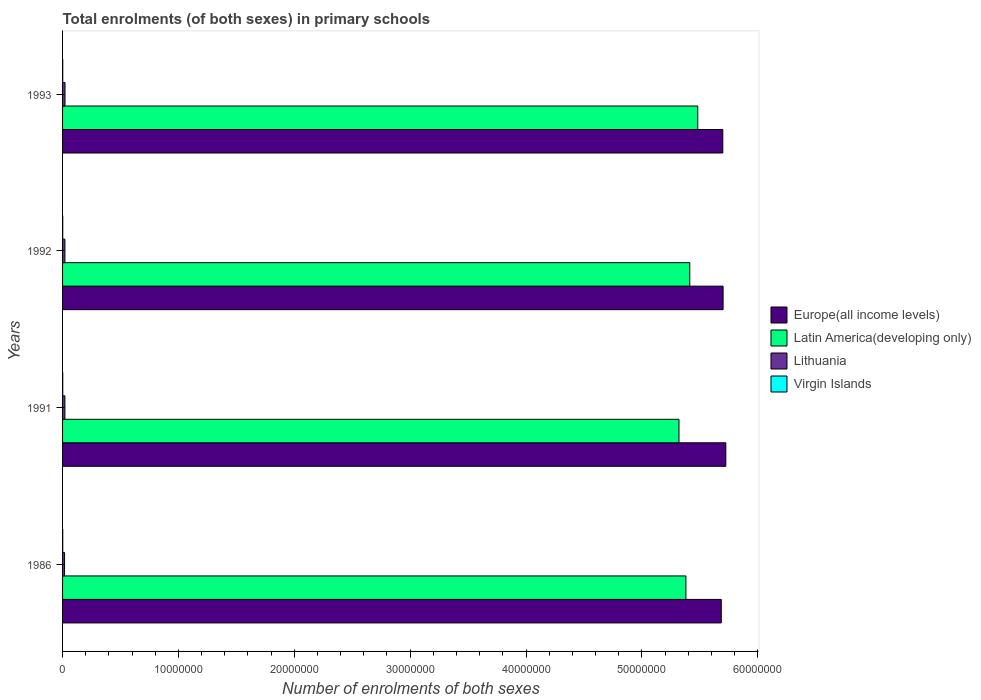Are the number of bars on each tick of the Y-axis equal?
Make the answer very short. Yes. How many bars are there on the 1st tick from the bottom?
Make the answer very short. 4. What is the number of enrolments in primary schools in Latin America(developing only) in 1993?
Your response must be concise. 5.48e+07. Across all years, what is the maximum number of enrolments in primary schools in Europe(all income levels)?
Keep it short and to the point. 5.72e+07. Across all years, what is the minimum number of enrolments in primary schools in Europe(all income levels)?
Ensure brevity in your answer.  5.69e+07. In which year was the number of enrolments in primary schools in Virgin Islands maximum?
Offer a terse response. 1986. What is the total number of enrolments in primary schools in Virgin Islands in the graph?
Your answer should be very brief. 5.82e+04. What is the difference between the number of enrolments in primary schools in Virgin Islands in 1992 and that in 1993?
Keep it short and to the point. -144. What is the difference between the number of enrolments in primary schools in Europe(all income levels) in 1992 and the number of enrolments in primary schools in Latin America(developing only) in 1986?
Offer a terse response. 3.21e+06. What is the average number of enrolments in primary schools in Lithuania per year?
Offer a very short reply. 1.97e+05. In the year 1991, what is the difference between the number of enrolments in primary schools in Virgin Islands and number of enrolments in primary schools in Europe(all income levels)?
Offer a terse response. -5.72e+07. In how many years, is the number of enrolments in primary schools in Virgin Islands greater than 4000000 ?
Offer a terse response. 0. What is the ratio of the number of enrolments in primary schools in Latin America(developing only) in 1986 to that in 1993?
Ensure brevity in your answer.  0.98. What is the difference between the highest and the second highest number of enrolments in primary schools in Europe(all income levels)?
Your answer should be very brief. 2.35e+05. What is the difference between the highest and the lowest number of enrolments in primary schools in Europe(all income levels)?
Keep it short and to the point. 3.91e+05. Is it the case that in every year, the sum of the number of enrolments in primary schools in Virgin Islands and number of enrolments in primary schools in Europe(all income levels) is greater than the sum of number of enrolments in primary schools in Lithuania and number of enrolments in primary schools in Latin America(developing only)?
Make the answer very short. No. What does the 2nd bar from the top in 1986 represents?
Provide a short and direct response. Lithuania. What does the 4th bar from the bottom in 1992 represents?
Provide a succinct answer. Virgin Islands. Are all the bars in the graph horizontal?
Ensure brevity in your answer.  Yes. How many years are there in the graph?
Give a very brief answer. 4. What is the difference between two consecutive major ticks on the X-axis?
Your response must be concise. 1.00e+07. Does the graph contain any zero values?
Offer a terse response. No. Does the graph contain grids?
Ensure brevity in your answer.  No. What is the title of the graph?
Give a very brief answer. Total enrolments (of both sexes) in primary schools. What is the label or title of the X-axis?
Your answer should be very brief. Number of enrolments of both sexes. What is the label or title of the Y-axis?
Provide a short and direct response. Years. What is the Number of enrolments of both sexes in Europe(all income levels) in 1986?
Your answer should be very brief. 5.69e+07. What is the Number of enrolments of both sexes of Latin America(developing only) in 1986?
Provide a succinct answer. 5.38e+07. What is the Number of enrolments of both sexes in Lithuania in 1986?
Your answer should be very brief. 1.72e+05. What is the Number of enrolments of both sexes of Virgin Islands in 1986?
Offer a very short reply. 1.49e+04. What is the Number of enrolments of both sexes in Europe(all income levels) in 1991?
Offer a very short reply. 5.72e+07. What is the Number of enrolments of both sexes in Latin America(developing only) in 1991?
Keep it short and to the point. 5.32e+07. What is the Number of enrolments of both sexes of Lithuania in 1991?
Provide a short and direct response. 2.02e+05. What is the Number of enrolments of both sexes in Virgin Islands in 1991?
Keep it short and to the point. 1.43e+04. What is the Number of enrolments of both sexes of Europe(all income levels) in 1992?
Offer a very short reply. 5.70e+07. What is the Number of enrolments of both sexes of Latin America(developing only) in 1992?
Your answer should be compact. 5.41e+07. What is the Number of enrolments of both sexes of Lithuania in 1992?
Your answer should be compact. 2.03e+05. What is the Number of enrolments of both sexes of Virgin Islands in 1992?
Make the answer very short. 1.44e+04. What is the Number of enrolments of both sexes in Europe(all income levels) in 1993?
Ensure brevity in your answer.  5.70e+07. What is the Number of enrolments of both sexes of Latin America(developing only) in 1993?
Offer a terse response. 5.48e+07. What is the Number of enrolments of both sexes in Lithuania in 1993?
Provide a succinct answer. 2.11e+05. What is the Number of enrolments of both sexes of Virgin Islands in 1993?
Ensure brevity in your answer.  1.45e+04. Across all years, what is the maximum Number of enrolments of both sexes of Europe(all income levels)?
Keep it short and to the point. 5.72e+07. Across all years, what is the maximum Number of enrolments of both sexes in Latin America(developing only)?
Give a very brief answer. 5.48e+07. Across all years, what is the maximum Number of enrolments of both sexes in Lithuania?
Your response must be concise. 2.11e+05. Across all years, what is the maximum Number of enrolments of both sexes in Virgin Islands?
Offer a very short reply. 1.49e+04. Across all years, what is the minimum Number of enrolments of both sexes in Europe(all income levels)?
Give a very brief answer. 5.69e+07. Across all years, what is the minimum Number of enrolments of both sexes of Latin America(developing only)?
Provide a short and direct response. 5.32e+07. Across all years, what is the minimum Number of enrolments of both sexes of Lithuania?
Provide a succinct answer. 1.72e+05. Across all years, what is the minimum Number of enrolments of both sexes of Virgin Islands?
Your answer should be compact. 1.43e+04. What is the total Number of enrolments of both sexes of Europe(all income levels) in the graph?
Keep it short and to the point. 2.28e+08. What is the total Number of enrolments of both sexes of Latin America(developing only) in the graph?
Make the answer very short. 2.16e+08. What is the total Number of enrolments of both sexes in Lithuania in the graph?
Your answer should be very brief. 7.88e+05. What is the total Number of enrolments of both sexes in Virgin Islands in the graph?
Provide a short and direct response. 5.82e+04. What is the difference between the Number of enrolments of both sexes of Europe(all income levels) in 1986 and that in 1991?
Keep it short and to the point. -3.91e+05. What is the difference between the Number of enrolments of both sexes in Latin America(developing only) in 1986 and that in 1991?
Make the answer very short. 5.98e+05. What is the difference between the Number of enrolments of both sexes of Lithuania in 1986 and that in 1991?
Ensure brevity in your answer.  -2.99e+04. What is the difference between the Number of enrolments of both sexes of Virgin Islands in 1986 and that in 1991?
Offer a terse response. 629. What is the difference between the Number of enrolments of both sexes in Europe(all income levels) in 1986 and that in 1992?
Your response must be concise. -1.56e+05. What is the difference between the Number of enrolments of both sexes in Latin America(developing only) in 1986 and that in 1992?
Ensure brevity in your answer.  -3.33e+05. What is the difference between the Number of enrolments of both sexes in Lithuania in 1986 and that in 1992?
Your response must be concise. -3.06e+04. What is the difference between the Number of enrolments of both sexes in Virgin Islands in 1986 and that in 1992?
Provide a succinct answer. 548. What is the difference between the Number of enrolments of both sexes in Europe(all income levels) in 1986 and that in 1993?
Offer a very short reply. -1.30e+05. What is the difference between the Number of enrolments of both sexes in Latin America(developing only) in 1986 and that in 1993?
Make the answer very short. -1.02e+06. What is the difference between the Number of enrolments of both sexes in Lithuania in 1986 and that in 1993?
Your answer should be very brief. -3.85e+04. What is the difference between the Number of enrolments of both sexes in Virgin Islands in 1986 and that in 1993?
Keep it short and to the point. 404. What is the difference between the Number of enrolments of both sexes in Europe(all income levels) in 1991 and that in 1992?
Provide a succinct answer. 2.35e+05. What is the difference between the Number of enrolments of both sexes of Latin America(developing only) in 1991 and that in 1992?
Make the answer very short. -9.30e+05. What is the difference between the Number of enrolments of both sexes of Lithuania in 1991 and that in 1992?
Ensure brevity in your answer.  -748. What is the difference between the Number of enrolments of both sexes of Virgin Islands in 1991 and that in 1992?
Ensure brevity in your answer.  -81. What is the difference between the Number of enrolments of both sexes in Europe(all income levels) in 1991 and that in 1993?
Keep it short and to the point. 2.60e+05. What is the difference between the Number of enrolments of both sexes in Latin America(developing only) in 1991 and that in 1993?
Provide a short and direct response. -1.62e+06. What is the difference between the Number of enrolments of both sexes in Lithuania in 1991 and that in 1993?
Your answer should be compact. -8612. What is the difference between the Number of enrolments of both sexes of Virgin Islands in 1991 and that in 1993?
Ensure brevity in your answer.  -225. What is the difference between the Number of enrolments of both sexes of Europe(all income levels) in 1992 and that in 1993?
Provide a succinct answer. 2.56e+04. What is the difference between the Number of enrolments of both sexes of Latin America(developing only) in 1992 and that in 1993?
Your response must be concise. -6.89e+05. What is the difference between the Number of enrolments of both sexes of Lithuania in 1992 and that in 1993?
Make the answer very short. -7864. What is the difference between the Number of enrolments of both sexes in Virgin Islands in 1992 and that in 1993?
Your answer should be very brief. -144. What is the difference between the Number of enrolments of both sexes of Europe(all income levels) in 1986 and the Number of enrolments of both sexes of Latin America(developing only) in 1991?
Give a very brief answer. 3.65e+06. What is the difference between the Number of enrolments of both sexes of Europe(all income levels) in 1986 and the Number of enrolments of both sexes of Lithuania in 1991?
Offer a very short reply. 5.67e+07. What is the difference between the Number of enrolments of both sexes in Europe(all income levels) in 1986 and the Number of enrolments of both sexes in Virgin Islands in 1991?
Your response must be concise. 5.68e+07. What is the difference between the Number of enrolments of both sexes in Latin America(developing only) in 1986 and the Number of enrolments of both sexes in Lithuania in 1991?
Make the answer very short. 5.36e+07. What is the difference between the Number of enrolments of both sexes in Latin America(developing only) in 1986 and the Number of enrolments of both sexes in Virgin Islands in 1991?
Make the answer very short. 5.38e+07. What is the difference between the Number of enrolments of both sexes of Lithuania in 1986 and the Number of enrolments of both sexes of Virgin Islands in 1991?
Offer a terse response. 1.58e+05. What is the difference between the Number of enrolments of both sexes of Europe(all income levels) in 1986 and the Number of enrolments of both sexes of Latin America(developing only) in 1992?
Offer a very short reply. 2.72e+06. What is the difference between the Number of enrolments of both sexes of Europe(all income levels) in 1986 and the Number of enrolments of both sexes of Lithuania in 1992?
Ensure brevity in your answer.  5.67e+07. What is the difference between the Number of enrolments of both sexes of Europe(all income levels) in 1986 and the Number of enrolments of both sexes of Virgin Islands in 1992?
Your answer should be very brief. 5.68e+07. What is the difference between the Number of enrolments of both sexes of Latin America(developing only) in 1986 and the Number of enrolments of both sexes of Lithuania in 1992?
Your answer should be very brief. 5.36e+07. What is the difference between the Number of enrolments of both sexes in Latin America(developing only) in 1986 and the Number of enrolments of both sexes in Virgin Islands in 1992?
Make the answer very short. 5.38e+07. What is the difference between the Number of enrolments of both sexes in Lithuania in 1986 and the Number of enrolments of both sexes in Virgin Islands in 1992?
Give a very brief answer. 1.58e+05. What is the difference between the Number of enrolments of both sexes in Europe(all income levels) in 1986 and the Number of enrolments of both sexes in Latin America(developing only) in 1993?
Your answer should be compact. 2.03e+06. What is the difference between the Number of enrolments of both sexes of Europe(all income levels) in 1986 and the Number of enrolments of both sexes of Lithuania in 1993?
Your answer should be compact. 5.66e+07. What is the difference between the Number of enrolments of both sexes of Europe(all income levels) in 1986 and the Number of enrolments of both sexes of Virgin Islands in 1993?
Offer a very short reply. 5.68e+07. What is the difference between the Number of enrolments of both sexes in Latin America(developing only) in 1986 and the Number of enrolments of both sexes in Lithuania in 1993?
Your response must be concise. 5.36e+07. What is the difference between the Number of enrolments of both sexes in Latin America(developing only) in 1986 and the Number of enrolments of both sexes in Virgin Islands in 1993?
Your answer should be compact. 5.38e+07. What is the difference between the Number of enrolments of both sexes of Lithuania in 1986 and the Number of enrolments of both sexes of Virgin Islands in 1993?
Offer a terse response. 1.58e+05. What is the difference between the Number of enrolments of both sexes in Europe(all income levels) in 1991 and the Number of enrolments of both sexes in Latin America(developing only) in 1992?
Provide a short and direct response. 3.11e+06. What is the difference between the Number of enrolments of both sexes of Europe(all income levels) in 1991 and the Number of enrolments of both sexes of Lithuania in 1992?
Keep it short and to the point. 5.70e+07. What is the difference between the Number of enrolments of both sexes of Europe(all income levels) in 1991 and the Number of enrolments of both sexes of Virgin Islands in 1992?
Offer a terse response. 5.72e+07. What is the difference between the Number of enrolments of both sexes of Latin America(developing only) in 1991 and the Number of enrolments of both sexes of Lithuania in 1992?
Your response must be concise. 5.30e+07. What is the difference between the Number of enrolments of both sexes of Latin America(developing only) in 1991 and the Number of enrolments of both sexes of Virgin Islands in 1992?
Ensure brevity in your answer.  5.32e+07. What is the difference between the Number of enrolments of both sexes in Lithuania in 1991 and the Number of enrolments of both sexes in Virgin Islands in 1992?
Keep it short and to the point. 1.88e+05. What is the difference between the Number of enrolments of both sexes of Europe(all income levels) in 1991 and the Number of enrolments of both sexes of Latin America(developing only) in 1993?
Your answer should be compact. 2.42e+06. What is the difference between the Number of enrolments of both sexes of Europe(all income levels) in 1991 and the Number of enrolments of both sexes of Lithuania in 1993?
Your answer should be very brief. 5.70e+07. What is the difference between the Number of enrolments of both sexes of Europe(all income levels) in 1991 and the Number of enrolments of both sexes of Virgin Islands in 1993?
Give a very brief answer. 5.72e+07. What is the difference between the Number of enrolments of both sexes in Latin America(developing only) in 1991 and the Number of enrolments of both sexes in Lithuania in 1993?
Keep it short and to the point. 5.30e+07. What is the difference between the Number of enrolments of both sexes in Latin America(developing only) in 1991 and the Number of enrolments of both sexes in Virgin Islands in 1993?
Give a very brief answer. 5.32e+07. What is the difference between the Number of enrolments of both sexes in Lithuania in 1991 and the Number of enrolments of both sexes in Virgin Islands in 1993?
Provide a succinct answer. 1.88e+05. What is the difference between the Number of enrolments of both sexes of Europe(all income levels) in 1992 and the Number of enrolments of both sexes of Latin America(developing only) in 1993?
Your answer should be very brief. 2.19e+06. What is the difference between the Number of enrolments of both sexes in Europe(all income levels) in 1992 and the Number of enrolments of both sexes in Lithuania in 1993?
Keep it short and to the point. 5.68e+07. What is the difference between the Number of enrolments of both sexes of Europe(all income levels) in 1992 and the Number of enrolments of both sexes of Virgin Islands in 1993?
Offer a very short reply. 5.70e+07. What is the difference between the Number of enrolments of both sexes of Latin America(developing only) in 1992 and the Number of enrolments of both sexes of Lithuania in 1993?
Your answer should be compact. 5.39e+07. What is the difference between the Number of enrolments of both sexes in Latin America(developing only) in 1992 and the Number of enrolments of both sexes in Virgin Islands in 1993?
Your answer should be compact. 5.41e+07. What is the difference between the Number of enrolments of both sexes of Lithuania in 1992 and the Number of enrolments of both sexes of Virgin Islands in 1993?
Give a very brief answer. 1.88e+05. What is the average Number of enrolments of both sexes in Europe(all income levels) per year?
Provide a succinct answer. 5.70e+07. What is the average Number of enrolments of both sexes in Latin America(developing only) per year?
Your answer should be very brief. 5.40e+07. What is the average Number of enrolments of both sexes of Lithuania per year?
Give a very brief answer. 1.97e+05. What is the average Number of enrolments of both sexes in Virgin Islands per year?
Ensure brevity in your answer.  1.46e+04. In the year 1986, what is the difference between the Number of enrolments of both sexes of Europe(all income levels) and Number of enrolments of both sexes of Latin America(developing only)?
Give a very brief answer. 3.05e+06. In the year 1986, what is the difference between the Number of enrolments of both sexes in Europe(all income levels) and Number of enrolments of both sexes in Lithuania?
Provide a short and direct response. 5.67e+07. In the year 1986, what is the difference between the Number of enrolments of both sexes of Europe(all income levels) and Number of enrolments of both sexes of Virgin Islands?
Make the answer very short. 5.68e+07. In the year 1986, what is the difference between the Number of enrolments of both sexes in Latin America(developing only) and Number of enrolments of both sexes in Lithuania?
Offer a very short reply. 5.36e+07. In the year 1986, what is the difference between the Number of enrolments of both sexes in Latin America(developing only) and Number of enrolments of both sexes in Virgin Islands?
Give a very brief answer. 5.38e+07. In the year 1986, what is the difference between the Number of enrolments of both sexes in Lithuania and Number of enrolments of both sexes in Virgin Islands?
Ensure brevity in your answer.  1.57e+05. In the year 1991, what is the difference between the Number of enrolments of both sexes of Europe(all income levels) and Number of enrolments of both sexes of Latin America(developing only)?
Your response must be concise. 4.04e+06. In the year 1991, what is the difference between the Number of enrolments of both sexes in Europe(all income levels) and Number of enrolments of both sexes in Lithuania?
Ensure brevity in your answer.  5.70e+07. In the year 1991, what is the difference between the Number of enrolments of both sexes of Europe(all income levels) and Number of enrolments of both sexes of Virgin Islands?
Offer a very short reply. 5.72e+07. In the year 1991, what is the difference between the Number of enrolments of both sexes in Latin America(developing only) and Number of enrolments of both sexes in Lithuania?
Offer a terse response. 5.30e+07. In the year 1991, what is the difference between the Number of enrolments of both sexes in Latin America(developing only) and Number of enrolments of both sexes in Virgin Islands?
Keep it short and to the point. 5.32e+07. In the year 1991, what is the difference between the Number of enrolments of both sexes of Lithuania and Number of enrolments of both sexes of Virgin Islands?
Your answer should be compact. 1.88e+05. In the year 1992, what is the difference between the Number of enrolments of both sexes of Europe(all income levels) and Number of enrolments of both sexes of Latin America(developing only)?
Provide a short and direct response. 2.88e+06. In the year 1992, what is the difference between the Number of enrolments of both sexes of Europe(all income levels) and Number of enrolments of both sexes of Lithuania?
Your answer should be very brief. 5.68e+07. In the year 1992, what is the difference between the Number of enrolments of both sexes of Europe(all income levels) and Number of enrolments of both sexes of Virgin Islands?
Offer a terse response. 5.70e+07. In the year 1992, what is the difference between the Number of enrolments of both sexes in Latin America(developing only) and Number of enrolments of both sexes in Lithuania?
Offer a very short reply. 5.39e+07. In the year 1992, what is the difference between the Number of enrolments of both sexes of Latin America(developing only) and Number of enrolments of both sexes of Virgin Islands?
Keep it short and to the point. 5.41e+07. In the year 1992, what is the difference between the Number of enrolments of both sexes of Lithuania and Number of enrolments of both sexes of Virgin Islands?
Your answer should be very brief. 1.89e+05. In the year 1993, what is the difference between the Number of enrolments of both sexes in Europe(all income levels) and Number of enrolments of both sexes in Latin America(developing only)?
Your answer should be very brief. 2.16e+06. In the year 1993, what is the difference between the Number of enrolments of both sexes of Europe(all income levels) and Number of enrolments of both sexes of Lithuania?
Your answer should be compact. 5.68e+07. In the year 1993, what is the difference between the Number of enrolments of both sexes of Europe(all income levels) and Number of enrolments of both sexes of Virgin Islands?
Offer a terse response. 5.70e+07. In the year 1993, what is the difference between the Number of enrolments of both sexes of Latin America(developing only) and Number of enrolments of both sexes of Lithuania?
Your answer should be compact. 5.46e+07. In the year 1993, what is the difference between the Number of enrolments of both sexes of Latin America(developing only) and Number of enrolments of both sexes of Virgin Islands?
Keep it short and to the point. 5.48e+07. In the year 1993, what is the difference between the Number of enrolments of both sexes in Lithuania and Number of enrolments of both sexes in Virgin Islands?
Your answer should be compact. 1.96e+05. What is the ratio of the Number of enrolments of both sexes in Latin America(developing only) in 1986 to that in 1991?
Your answer should be compact. 1.01. What is the ratio of the Number of enrolments of both sexes in Lithuania in 1986 to that in 1991?
Provide a succinct answer. 0.85. What is the ratio of the Number of enrolments of both sexes in Virgin Islands in 1986 to that in 1991?
Offer a very short reply. 1.04. What is the ratio of the Number of enrolments of both sexes in Lithuania in 1986 to that in 1992?
Make the answer very short. 0.85. What is the ratio of the Number of enrolments of both sexes in Virgin Islands in 1986 to that in 1992?
Your answer should be compact. 1.04. What is the ratio of the Number of enrolments of both sexes of Europe(all income levels) in 1986 to that in 1993?
Your response must be concise. 1. What is the ratio of the Number of enrolments of both sexes of Latin America(developing only) in 1986 to that in 1993?
Give a very brief answer. 0.98. What is the ratio of the Number of enrolments of both sexes of Lithuania in 1986 to that in 1993?
Your answer should be very brief. 0.82. What is the ratio of the Number of enrolments of both sexes in Virgin Islands in 1986 to that in 1993?
Give a very brief answer. 1.03. What is the ratio of the Number of enrolments of both sexes in Europe(all income levels) in 1991 to that in 1992?
Offer a terse response. 1. What is the ratio of the Number of enrolments of both sexes in Latin America(developing only) in 1991 to that in 1992?
Your answer should be compact. 0.98. What is the ratio of the Number of enrolments of both sexes of Lithuania in 1991 to that in 1992?
Your response must be concise. 1. What is the ratio of the Number of enrolments of both sexes in Europe(all income levels) in 1991 to that in 1993?
Provide a succinct answer. 1. What is the ratio of the Number of enrolments of both sexes of Latin America(developing only) in 1991 to that in 1993?
Provide a short and direct response. 0.97. What is the ratio of the Number of enrolments of both sexes in Lithuania in 1991 to that in 1993?
Give a very brief answer. 0.96. What is the ratio of the Number of enrolments of both sexes of Virgin Islands in 1991 to that in 1993?
Ensure brevity in your answer.  0.98. What is the ratio of the Number of enrolments of both sexes in Latin America(developing only) in 1992 to that in 1993?
Keep it short and to the point. 0.99. What is the ratio of the Number of enrolments of both sexes of Lithuania in 1992 to that in 1993?
Your response must be concise. 0.96. What is the difference between the highest and the second highest Number of enrolments of both sexes in Europe(all income levels)?
Ensure brevity in your answer.  2.35e+05. What is the difference between the highest and the second highest Number of enrolments of both sexes of Latin America(developing only)?
Offer a terse response. 6.89e+05. What is the difference between the highest and the second highest Number of enrolments of both sexes in Lithuania?
Your answer should be compact. 7864. What is the difference between the highest and the second highest Number of enrolments of both sexes in Virgin Islands?
Your response must be concise. 404. What is the difference between the highest and the lowest Number of enrolments of both sexes in Europe(all income levels)?
Make the answer very short. 3.91e+05. What is the difference between the highest and the lowest Number of enrolments of both sexes of Latin America(developing only)?
Your answer should be compact. 1.62e+06. What is the difference between the highest and the lowest Number of enrolments of both sexes of Lithuania?
Offer a terse response. 3.85e+04. What is the difference between the highest and the lowest Number of enrolments of both sexes in Virgin Islands?
Your answer should be compact. 629. 